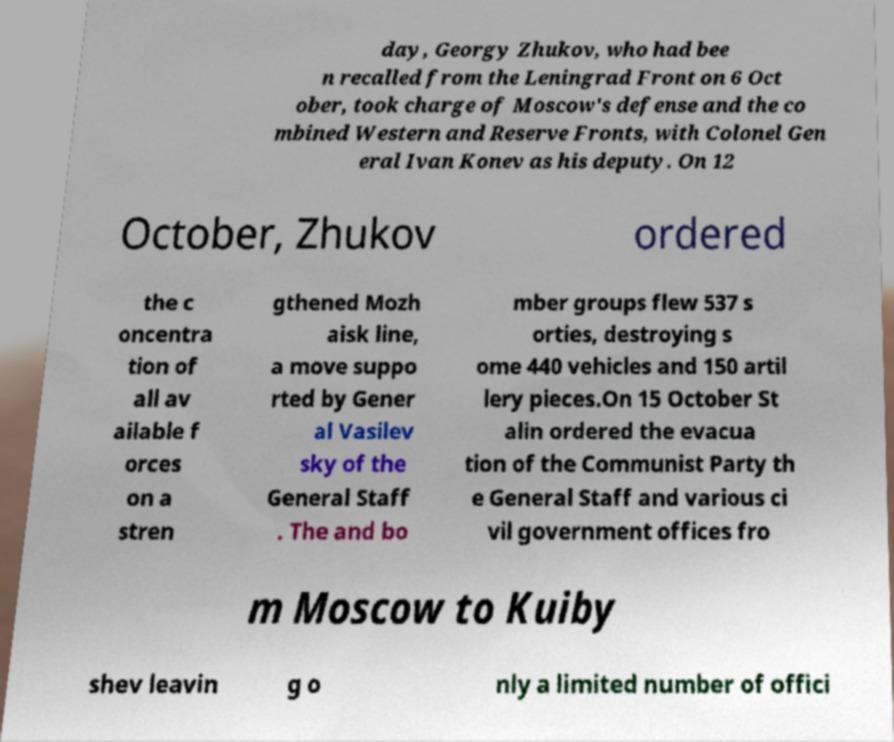Could you assist in decoding the text presented in this image and type it out clearly? day, Georgy Zhukov, who had bee n recalled from the Leningrad Front on 6 Oct ober, took charge of Moscow's defense and the co mbined Western and Reserve Fronts, with Colonel Gen eral Ivan Konev as his deputy. On 12 October, Zhukov ordered the c oncentra tion of all av ailable f orces on a stren gthened Mozh aisk line, a move suppo rted by Gener al Vasilev sky of the General Staff . The and bo mber groups flew 537 s orties, destroying s ome 440 vehicles and 150 artil lery pieces.On 15 October St alin ordered the evacua tion of the Communist Party th e General Staff and various ci vil government offices fro m Moscow to Kuiby shev leavin g o nly a limited number of offici 